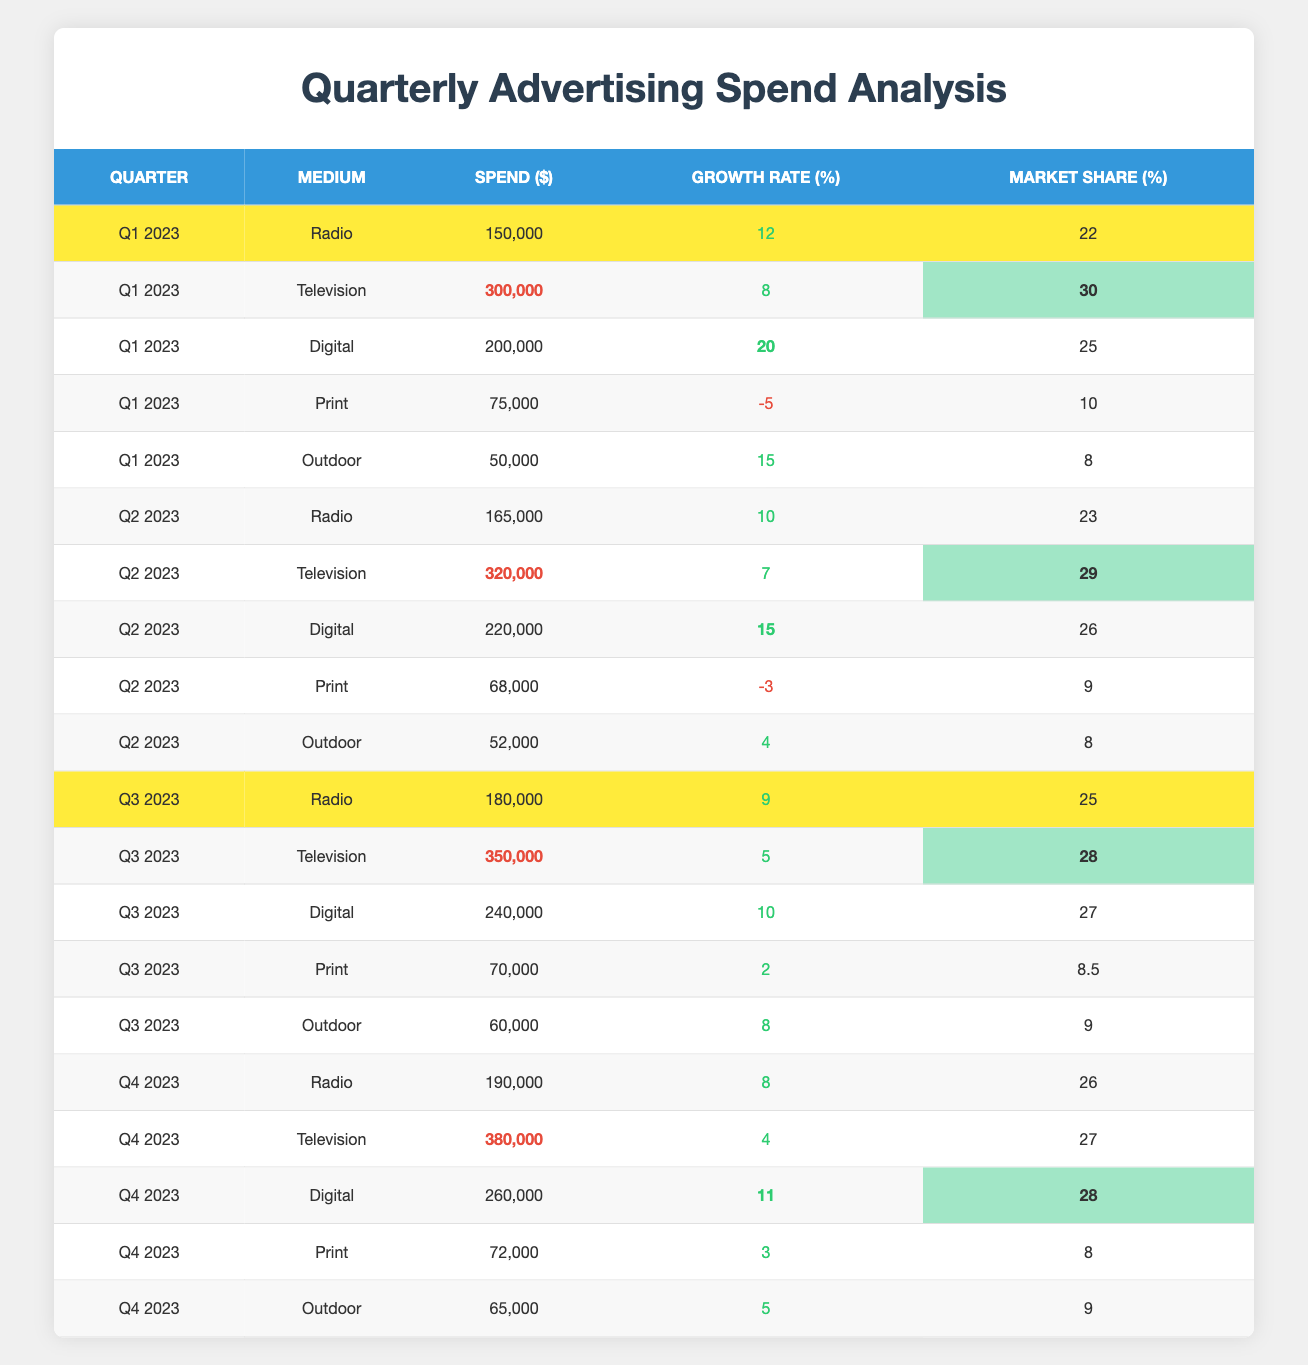What was the total advertising spend on Radio in Q2 2023? The table shows that the spend on Radio in Q2 2023 was 165,000.
Answer: 165,000 Which medium had the highest spend in Q3 2023? In Q3 2023, the table shows that Television had the highest spend at 350,000.
Answer: Television What is the growth rate of Print advertising in Q1 2023? The growth rate of Print advertising in Q1 2023 is listed as -5 in the table.
Answer: -5 How much did Digital advertising spend grow from Q1 2023 to Q2 2023? The spend on Digital in Q1 2023 was 200,000, and in Q2 2023 it was 220,000. The growth is calculated as 220,000 - 200,000 = 20,000.
Answer: 20,000 Which medium had a negative growth rate in Q2 2023? Looking at Q2 2023, the table shows that Print had a negative growth rate of -3.
Answer: Print In which quarter did Outdoor advertising spend see its highest increase? To find out the highest increase for Outdoor, I compare the spends: Q1 (50,000), Q2 (52,000), Q3 (60,000), and Q4 (65,000). The highest increase is from Q3 to Q4: 65,000 - 60,000 = 5,000.
Answer: Q4 2023 Is the market share of Radio advertising higher in Q4 2023 compared to Q1 2023? In Q1 2023, Radio's market share is 22, and in Q4 2023 it is 26. Since 26 is greater than 22, the statement is true.
Answer: Yes What was the average spend on Television across all four quarters? Summing the Television spends: Q1 (300,000) + Q2 (320,000) + Q3 (350,000) + Q4 (380,000) = 1,350,000. Dividing by 4 (the number of quarters) gives an average of 1,350,000 / 4 = 337,500.
Answer: 337,500 Which medium had the highest market share in Q3 2023? The table indicates that in Q3 2023, Television has the highest market share at 28.
Answer: Television What is the total market share of all mediums in Q1 2023? Adding the market shares in Q1 2023: 22 (Radio) + 30 (Television) + 25 (Digital) + 10 (Print) + 8 (Outdoor) equals 95.
Answer: 95 Which medium consistently showed a growth rate below zero? By checking each quarter's growth rates, Print shows a negative growth rate in Q1 (-5) and Q2 (-3), indicating consistent underperformance.
Answer: Print 